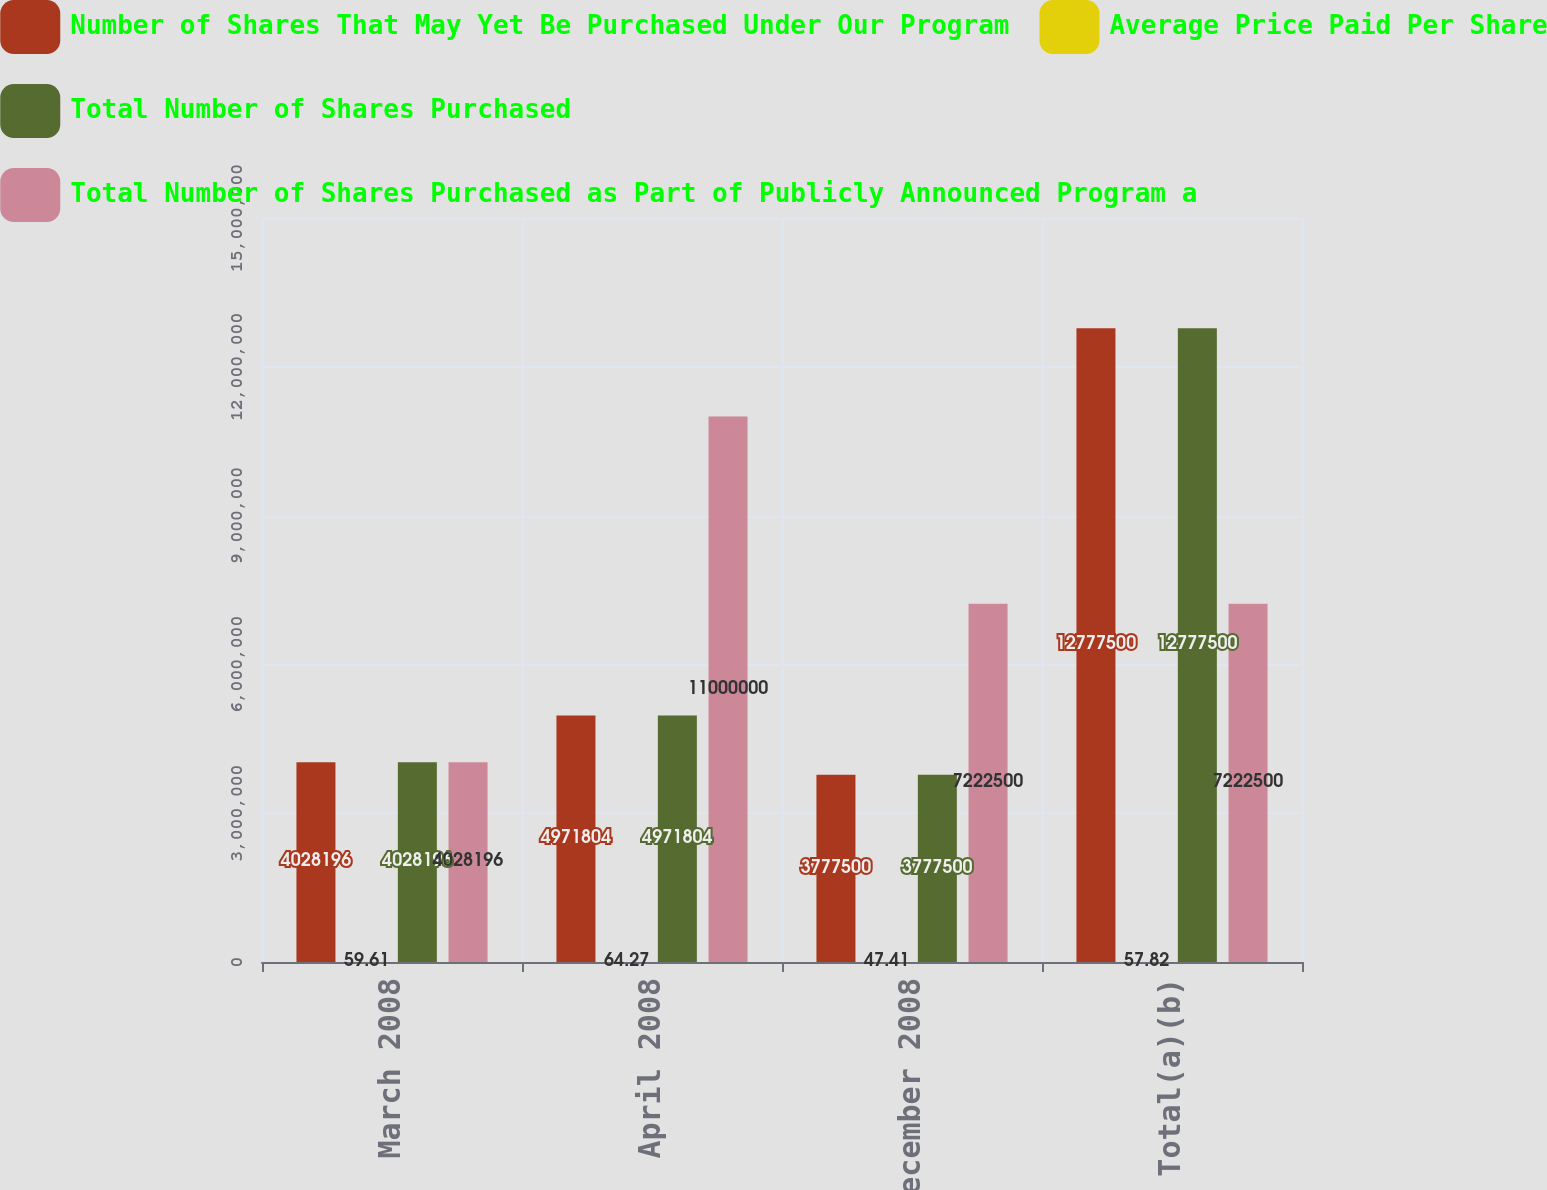<chart> <loc_0><loc_0><loc_500><loc_500><stacked_bar_chart><ecel><fcel>March 2008<fcel>April 2008<fcel>December 2008<fcel>Total(a)(b)<nl><fcel>Number of Shares That May Yet Be Purchased Under Our Program<fcel>4.0282e+06<fcel>4.9718e+06<fcel>3.7775e+06<fcel>1.27775e+07<nl><fcel>Average Price Paid Per Share<fcel>59.61<fcel>64.27<fcel>47.41<fcel>57.82<nl><fcel>Total Number of Shares Purchased<fcel>4.0282e+06<fcel>4.9718e+06<fcel>3.7775e+06<fcel>1.27775e+07<nl><fcel>Total Number of Shares Purchased as Part of Publicly Announced Program a<fcel>4.0282e+06<fcel>1.1e+07<fcel>7.2225e+06<fcel>7.2225e+06<nl></chart> 